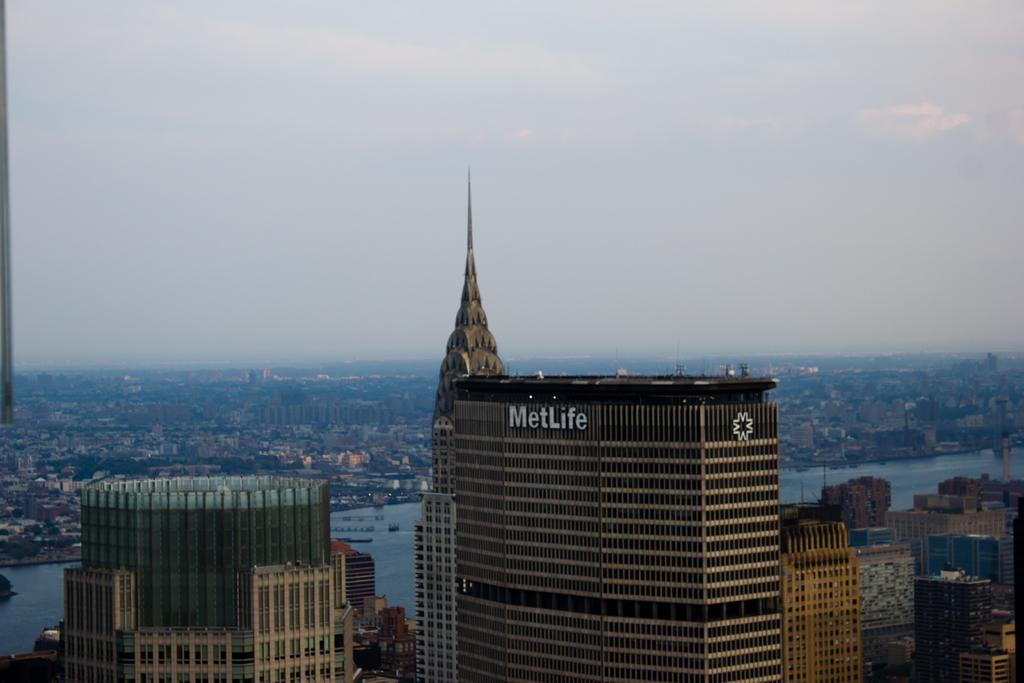What structures are present in the image? There are buildings in the image. What feature do the buildings have? The buildings have windows. What can be seen in the background of the image? The sky is visible in the background of the image. What type of butter is being used to paint the flowers in the image? There are no butter or flowers present in the image; it features buildings with windows and a visible sky in the background. 